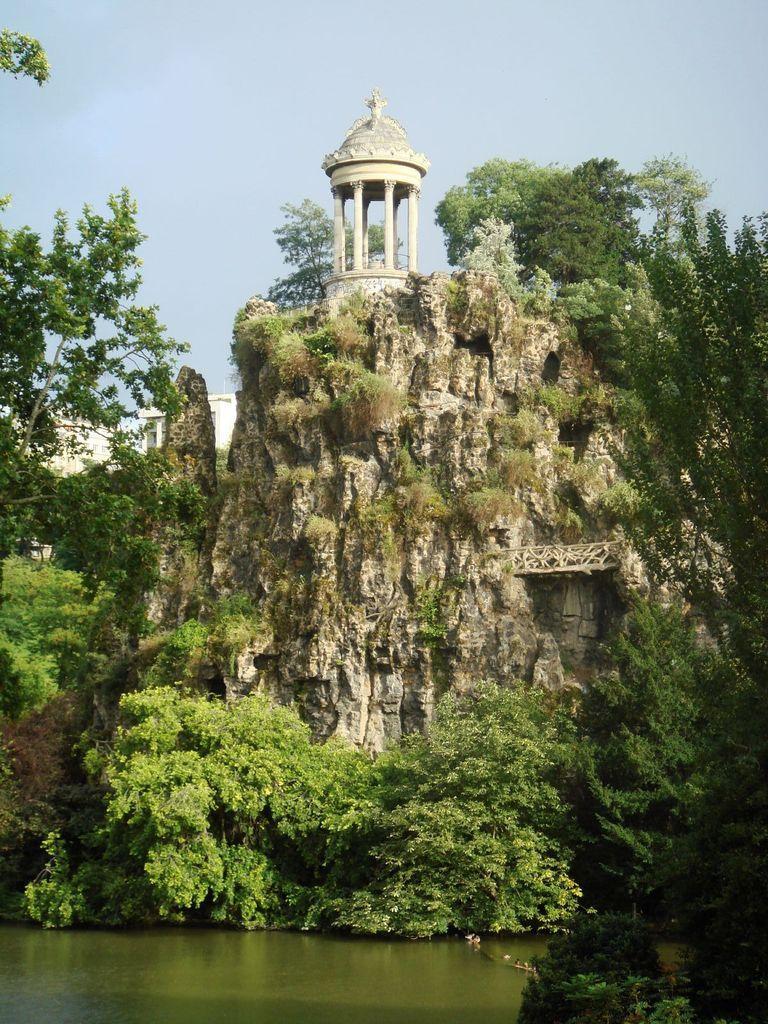Can you describe this image briefly? In this image we can see rocks, trees, buildings and sky. 